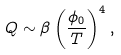Convert formula to latex. <formula><loc_0><loc_0><loc_500><loc_500>Q \sim \beta \left ( \frac { \phi _ { 0 } } { T } \right ) ^ { 4 } ,</formula> 